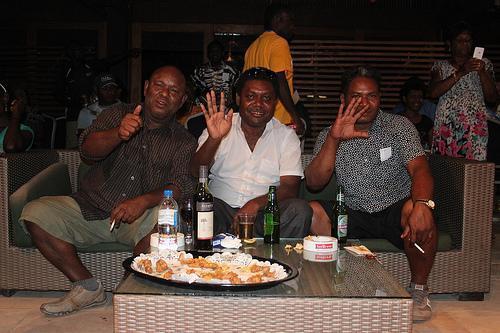How many men are on the couch?
Give a very brief answer. 3. 